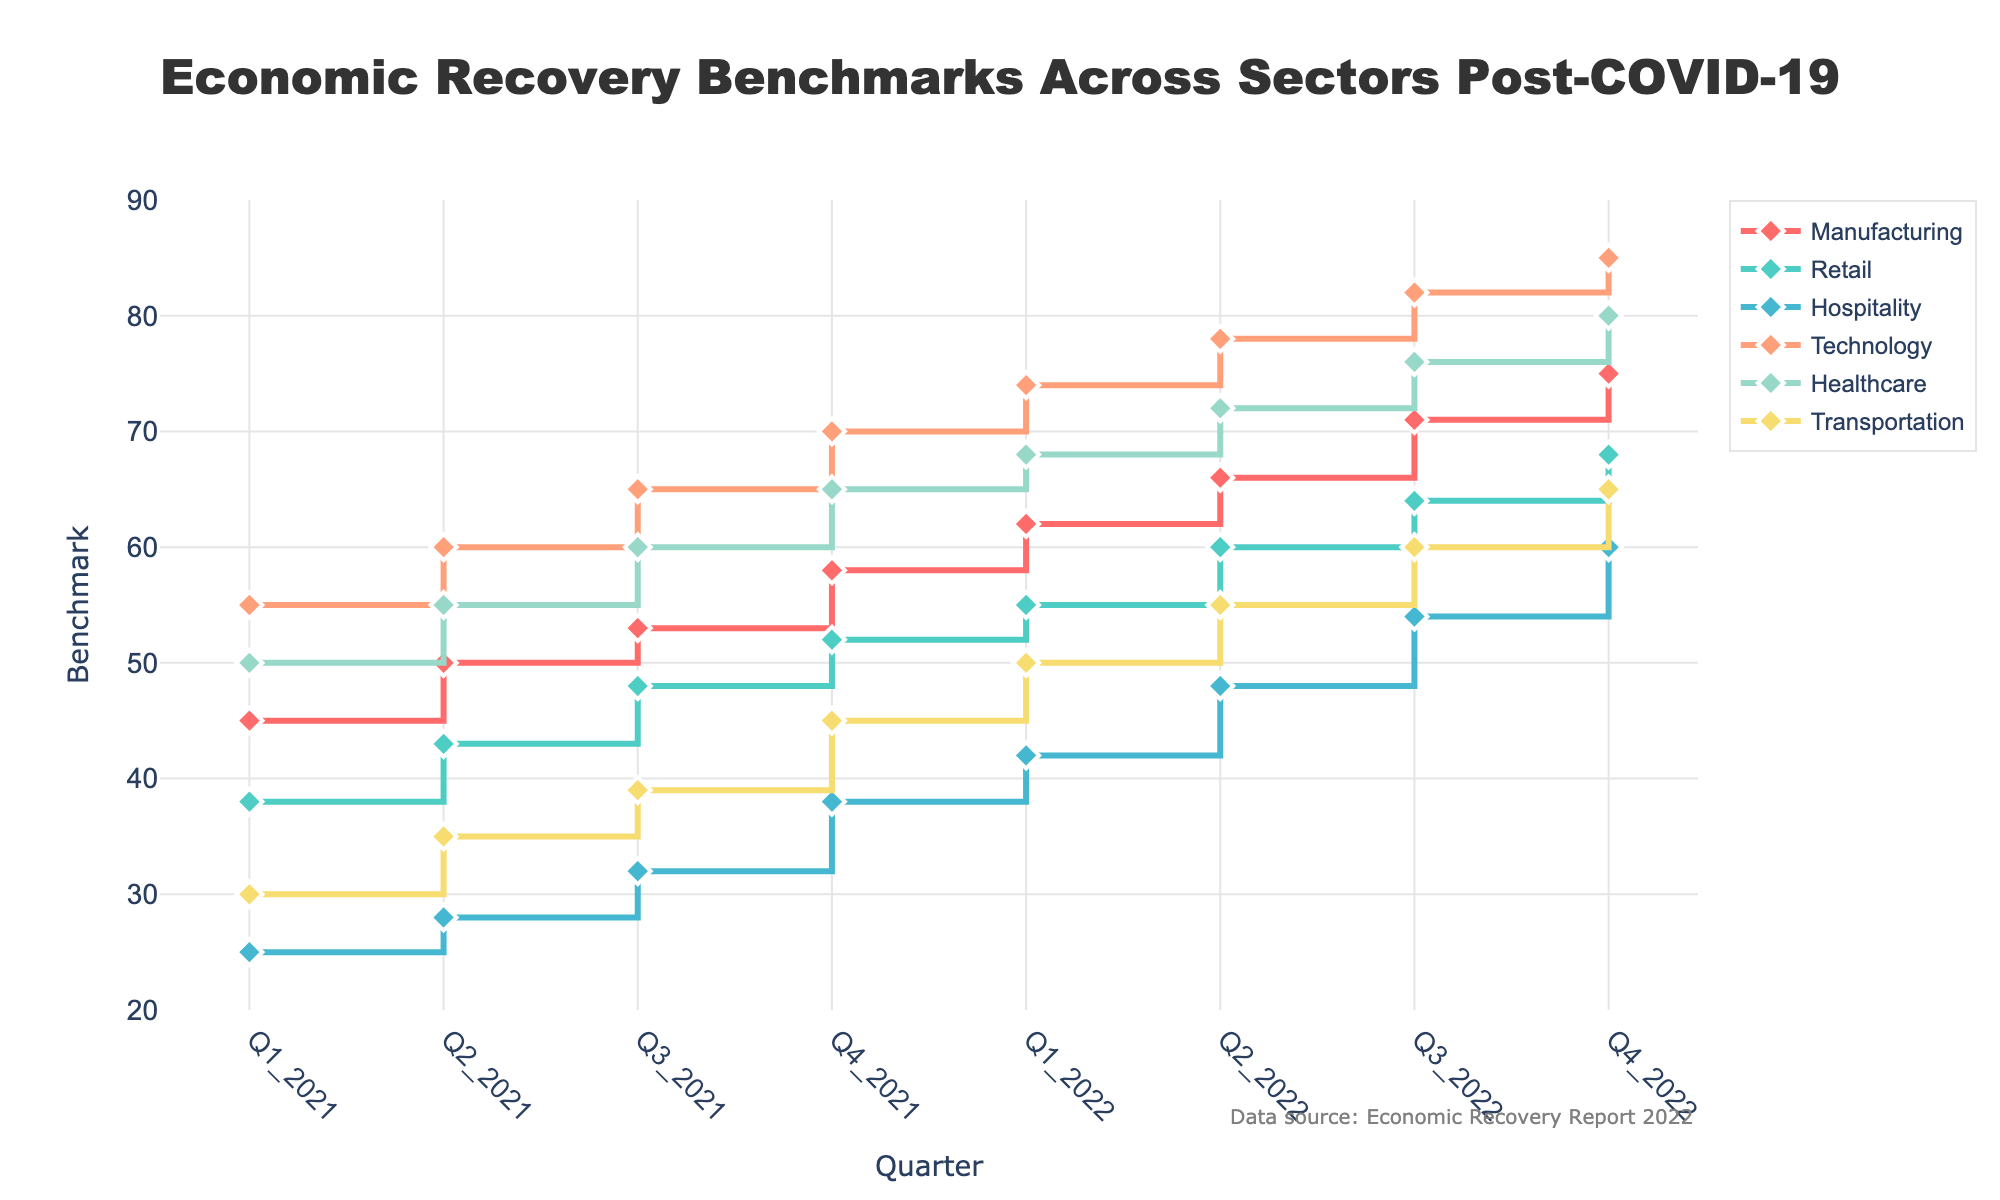What's the title of the figure? The title is prominently displayed at the top center of the figure.
Answer: Economic Recovery Benchmarks Across Sectors Post-COVID-19 Which sector shows the highest benchmark in Q4 2022? To find this, look for the highest value at the last marker on the X-axis, which is labeled Q4 2022.
Answer: Technology During which quarter does the Retail sector first surpass a benchmark of 50? Look at the plotted points for the Retail sector and find where the benchmark value first exceeds 50.
Answer: Q3 2021 How many quarters show an increase in the benchmark for the Manufacturing sector? Examine the stair plot for the Manufacturing sector to count the number of increments from one quarter to the next.
Answer: 7 Which sector has the most consistent increase in benchmarks across all quarters? Compare the stair-like consistency of the lines across all sectors. Look for a line with a steady upward trend without any deviations.
Answer: Technology What is the difference in the benchmark values between Q1 2021 and Q4 2022 for the Healthcare sector? Subtract the Q1 2021 value from the Q4 2022 value for Healthcare.
Answer: 30 Which sector experienced the largest increase in benchmark from Q1 2022 to Q2 2022? Calculate the difference between Q1 2022 and Q2 2022 for all sectors and identify the largest one.
Answer: Hospitality On average, what is the benchmark value for the Transportation sector over all quarters shown in the figure? Sum the benchmark values for the Transportation sector across all quarters and divide by the number of data points (8).
Answer: 47.38 Which sector had the slowest recovery post-COVID-19 up to Q4 2022? Look at the overall upward trajectory of each sector and identify the one with the least improvement from Q1 2021 to Q4 2022.
Answer: Hospitality 